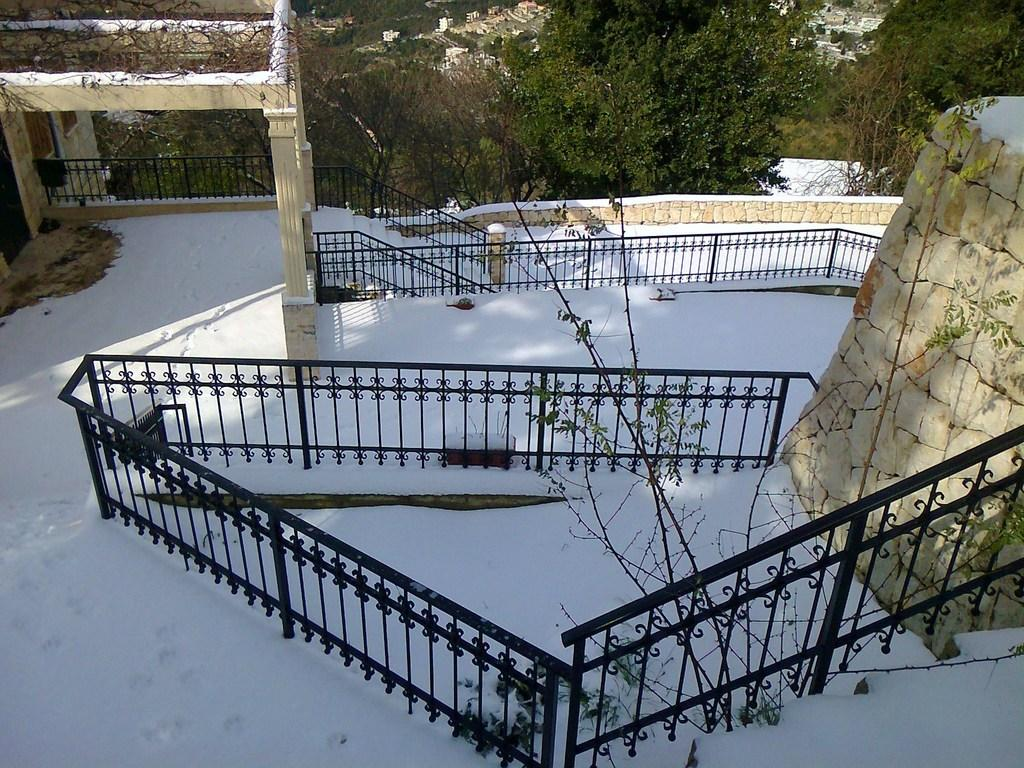What type of structure is visible in the image? There is a building with a fence in the image. What is the condition of the fence in the image? The fence is covered with snow. What other natural elements can be seen in the image? There are trees in the image. Are there any other buildings visible in the image? Yes, there are other buildings in the image. What is the title of the book being read by the passenger in the image? There is no book or passenger present in the image. How does the roll of paper towels move in the image? There is no roll of paper towels present in the image. 